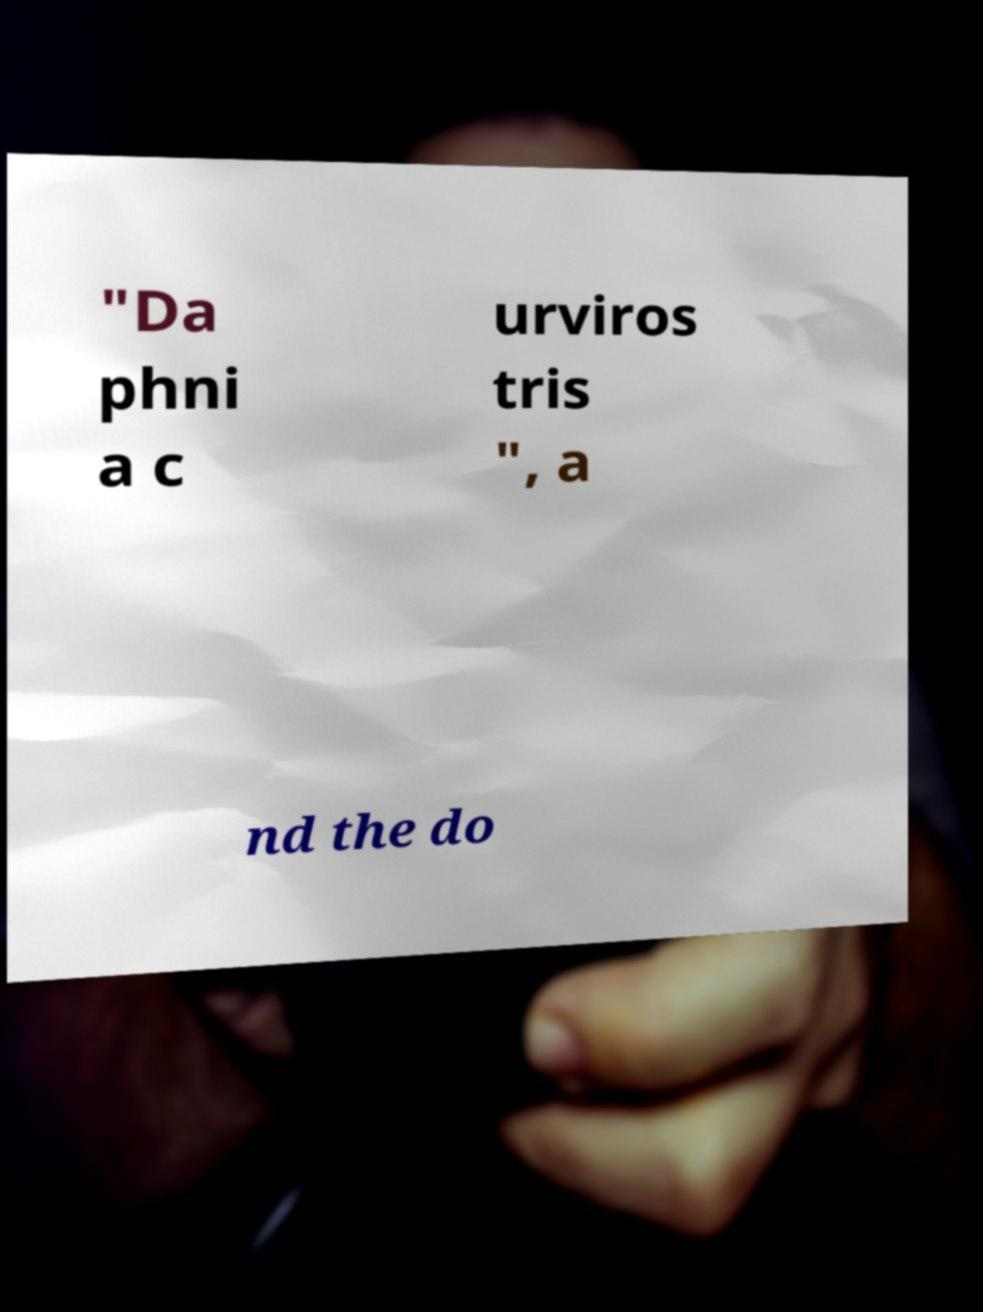Please read and relay the text visible in this image. What does it say? "Da phni a c urviros tris ", a nd the do 